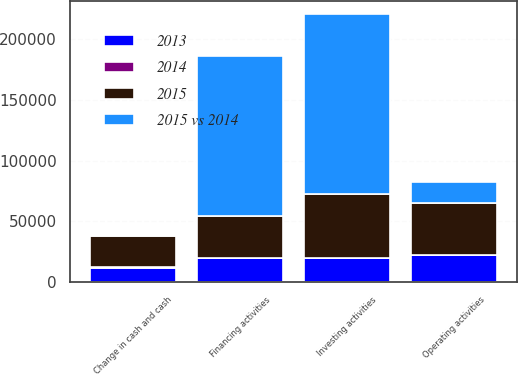Convert chart to OTSL. <chart><loc_0><loc_0><loc_500><loc_500><stacked_bar_chart><ecel><fcel>Operating activities<fcel>Investing activities<fcel>Financing activities<fcel>Change in cash and cash<nl><fcel>2015<fcel>42972<fcel>52324<fcel>34922<fcel>25570<nl><fcel>2013<fcel>22337<fcel>19660.5<fcel>19660.5<fcel>11782<nl><fcel>2015 vs 2014<fcel>16984<fcel>148432<fcel>131375<fcel>73<nl><fcel>2014<fcel>92<fcel>76<fcel>83<fcel>117<nl></chart> 